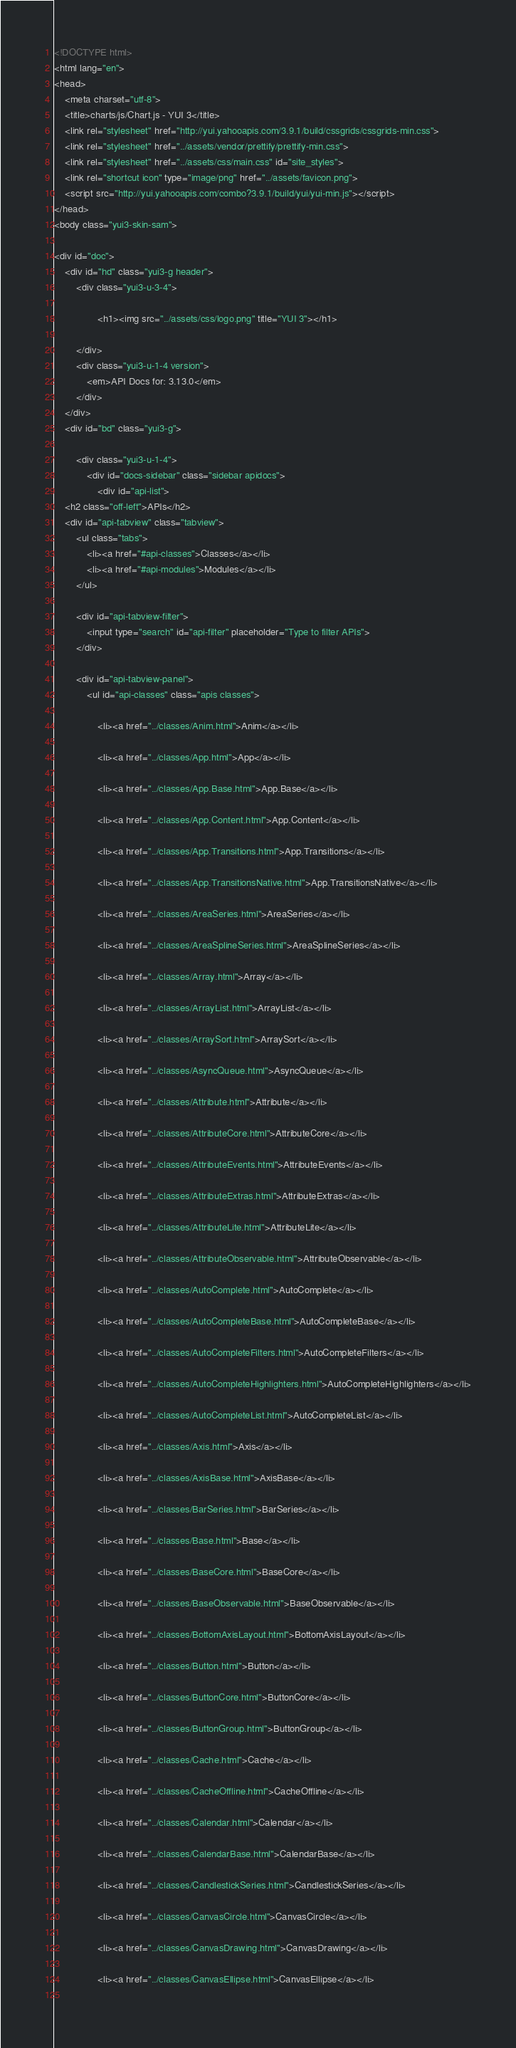Convert code to text. <code><loc_0><loc_0><loc_500><loc_500><_HTML_><!DOCTYPE html>
<html lang="en">
<head>
    <meta charset="utf-8">
    <title>charts/js/Chart.js - YUI 3</title>
    <link rel="stylesheet" href="http://yui.yahooapis.com/3.9.1/build/cssgrids/cssgrids-min.css">
    <link rel="stylesheet" href="../assets/vendor/prettify/prettify-min.css">
    <link rel="stylesheet" href="../assets/css/main.css" id="site_styles">
    <link rel="shortcut icon" type="image/png" href="../assets/favicon.png">
    <script src="http://yui.yahooapis.com/combo?3.9.1/build/yui/yui-min.js"></script>
</head>
<body class="yui3-skin-sam">

<div id="doc">
    <div id="hd" class="yui3-g header">
        <div class="yui3-u-3-4">
            
                <h1><img src="../assets/css/logo.png" title="YUI 3"></h1>
            
        </div>
        <div class="yui3-u-1-4 version">
            <em>API Docs for: 3.13.0</em>
        </div>
    </div>
    <div id="bd" class="yui3-g">

        <div class="yui3-u-1-4">
            <div id="docs-sidebar" class="sidebar apidocs">
                <div id="api-list">
    <h2 class="off-left">APIs</h2>
    <div id="api-tabview" class="tabview">
        <ul class="tabs">
            <li><a href="#api-classes">Classes</a></li>
            <li><a href="#api-modules">Modules</a></li>
        </ul>

        <div id="api-tabview-filter">
            <input type="search" id="api-filter" placeholder="Type to filter APIs">
        </div>

        <div id="api-tabview-panel">
            <ul id="api-classes" class="apis classes">
            
                <li><a href="../classes/Anim.html">Anim</a></li>
            
                <li><a href="../classes/App.html">App</a></li>
            
                <li><a href="../classes/App.Base.html">App.Base</a></li>
            
                <li><a href="../classes/App.Content.html">App.Content</a></li>
            
                <li><a href="../classes/App.Transitions.html">App.Transitions</a></li>
            
                <li><a href="../classes/App.TransitionsNative.html">App.TransitionsNative</a></li>
            
                <li><a href="../classes/AreaSeries.html">AreaSeries</a></li>
            
                <li><a href="../classes/AreaSplineSeries.html">AreaSplineSeries</a></li>
            
                <li><a href="../classes/Array.html">Array</a></li>
            
                <li><a href="../classes/ArrayList.html">ArrayList</a></li>
            
                <li><a href="../classes/ArraySort.html">ArraySort</a></li>
            
                <li><a href="../classes/AsyncQueue.html">AsyncQueue</a></li>
            
                <li><a href="../classes/Attribute.html">Attribute</a></li>
            
                <li><a href="../classes/AttributeCore.html">AttributeCore</a></li>
            
                <li><a href="../classes/AttributeEvents.html">AttributeEvents</a></li>
            
                <li><a href="../classes/AttributeExtras.html">AttributeExtras</a></li>
            
                <li><a href="../classes/AttributeLite.html">AttributeLite</a></li>
            
                <li><a href="../classes/AttributeObservable.html">AttributeObservable</a></li>
            
                <li><a href="../classes/AutoComplete.html">AutoComplete</a></li>
            
                <li><a href="../classes/AutoCompleteBase.html">AutoCompleteBase</a></li>
            
                <li><a href="../classes/AutoCompleteFilters.html">AutoCompleteFilters</a></li>
            
                <li><a href="../classes/AutoCompleteHighlighters.html">AutoCompleteHighlighters</a></li>
            
                <li><a href="../classes/AutoCompleteList.html">AutoCompleteList</a></li>
            
                <li><a href="../classes/Axis.html">Axis</a></li>
            
                <li><a href="../classes/AxisBase.html">AxisBase</a></li>
            
                <li><a href="../classes/BarSeries.html">BarSeries</a></li>
            
                <li><a href="../classes/Base.html">Base</a></li>
            
                <li><a href="../classes/BaseCore.html">BaseCore</a></li>
            
                <li><a href="../classes/BaseObservable.html">BaseObservable</a></li>
            
                <li><a href="../classes/BottomAxisLayout.html">BottomAxisLayout</a></li>
            
                <li><a href="../classes/Button.html">Button</a></li>
            
                <li><a href="../classes/ButtonCore.html">ButtonCore</a></li>
            
                <li><a href="../classes/ButtonGroup.html">ButtonGroup</a></li>
            
                <li><a href="../classes/Cache.html">Cache</a></li>
            
                <li><a href="../classes/CacheOffline.html">CacheOffline</a></li>
            
                <li><a href="../classes/Calendar.html">Calendar</a></li>
            
                <li><a href="../classes/CalendarBase.html">CalendarBase</a></li>
            
                <li><a href="../classes/CandlestickSeries.html">CandlestickSeries</a></li>
            
                <li><a href="../classes/CanvasCircle.html">CanvasCircle</a></li>
            
                <li><a href="../classes/CanvasDrawing.html">CanvasDrawing</a></li>
            
                <li><a href="../classes/CanvasEllipse.html">CanvasEllipse</a></li>
            </code> 